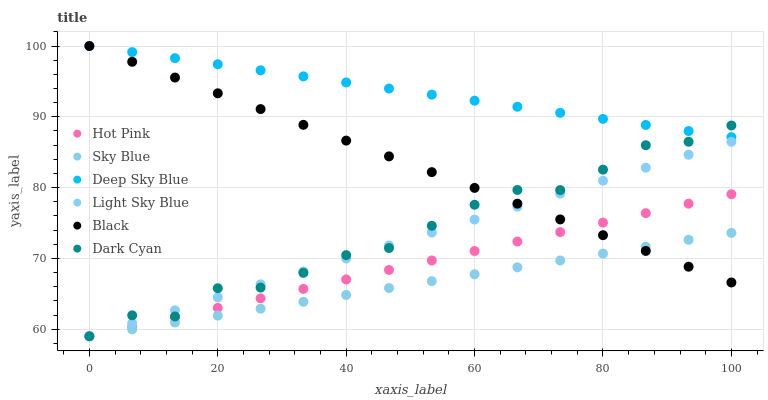Does Sky Blue have the minimum area under the curve?
Answer yes or no. Yes. Does Deep Sky Blue have the maximum area under the curve?
Answer yes or no. Yes. Does Light Sky Blue have the minimum area under the curve?
Answer yes or no. No. Does Light Sky Blue have the maximum area under the curve?
Answer yes or no. No. Is Black the smoothest?
Answer yes or no. Yes. Is Dark Cyan the roughest?
Answer yes or no. Yes. Is Light Sky Blue the smoothest?
Answer yes or no. No. Is Light Sky Blue the roughest?
Answer yes or no. No. Does Hot Pink have the lowest value?
Answer yes or no. Yes. Does Black have the lowest value?
Answer yes or no. No. Does Deep Sky Blue have the highest value?
Answer yes or no. Yes. Does Light Sky Blue have the highest value?
Answer yes or no. No. Is Light Sky Blue less than Deep Sky Blue?
Answer yes or no. Yes. Is Deep Sky Blue greater than Sky Blue?
Answer yes or no. Yes. Does Sky Blue intersect Hot Pink?
Answer yes or no. Yes. Is Sky Blue less than Hot Pink?
Answer yes or no. No. Is Sky Blue greater than Hot Pink?
Answer yes or no. No. Does Light Sky Blue intersect Deep Sky Blue?
Answer yes or no. No. 